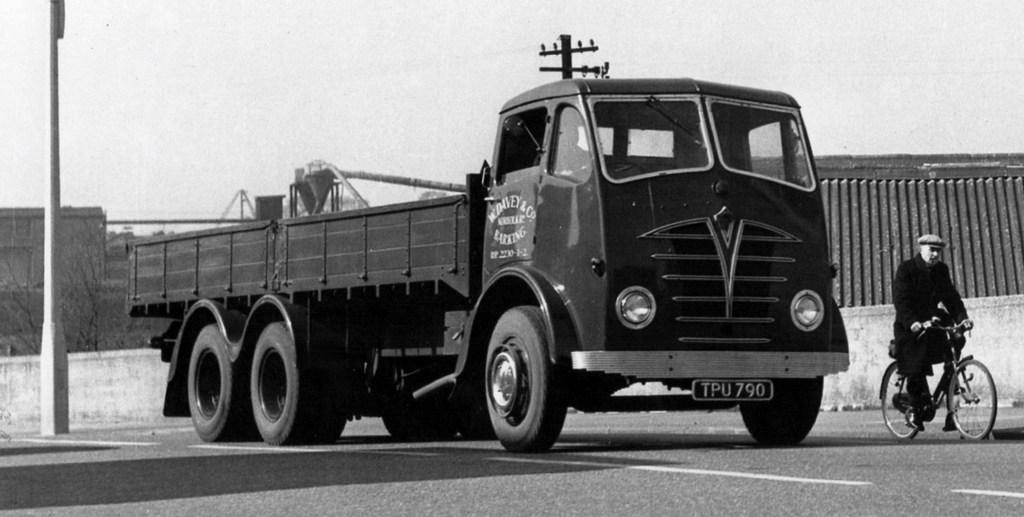Who is present in the image? There is a man in the image. What is the man doing in the image? The man is sitting on a bicycle. What other vehicle is present in the image? There is a lorry parked beside the man. What is the color scheme of the image? The image is in black and white color. What type of stream can be seen flowing near the man in the image? There is no stream present in the image; it only features a man sitting on a bicycle and a parked lorry. 